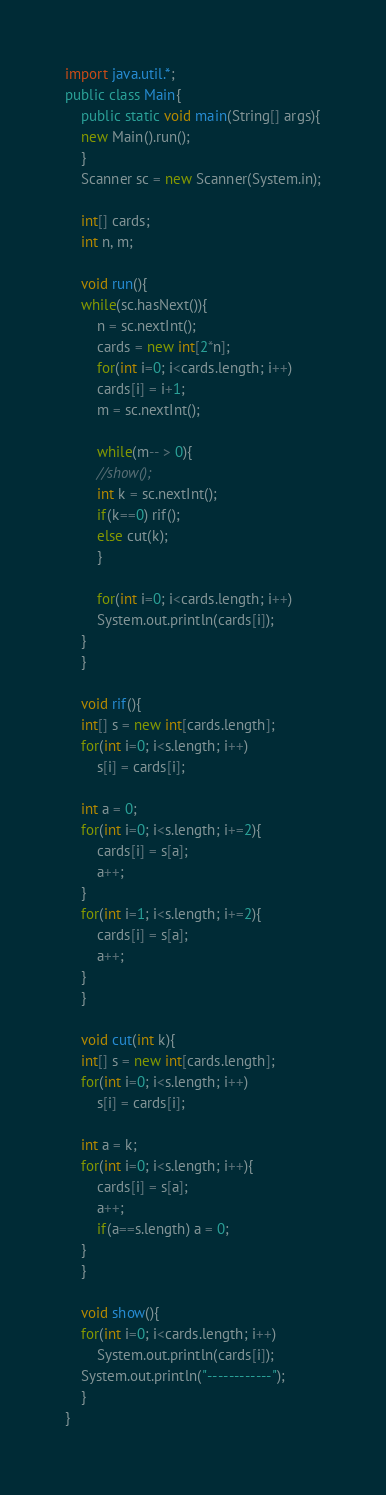Convert code to text. <code><loc_0><loc_0><loc_500><loc_500><_Java_>import java.util.*;
public class Main{
    public static void main(String[] args){
	new Main().run();
    }
    Scanner sc = new Scanner(System.in);

    int[] cards;
    int n, m;

    void run(){
	while(sc.hasNext()){
	    n = sc.nextInt();
	    cards = new int[2*n];
	    for(int i=0; i<cards.length; i++)
		cards[i] = i+1;
	    m = sc.nextInt();

	    while(m-- > 0){
		//show();
		int k = sc.nextInt();
		if(k==0) rif();
		else cut(k);
	    }

	    for(int i=0; i<cards.length; i++)
		System.out.println(cards[i]);
	}
    }

    void rif(){
	int[] s = new int[cards.length];
	for(int i=0; i<s.length; i++)
	    s[i] = cards[i];

	int a = 0;
	for(int i=0; i<s.length; i+=2){
	    cards[i] = s[a];
	    a++;
	}
	for(int i=1; i<s.length; i+=2){
	    cards[i] = s[a];
	    a++;
	}
    }

    void cut(int k){
	int[] s = new int[cards.length];
	for(int i=0; i<s.length; i++)
	    s[i] = cards[i];

	int a = k;
	for(int i=0; i<s.length; i++){
	    cards[i] = s[a];
	    a++;
	    if(a==s.length) a = 0;
	}
    }

    void show(){
	for(int i=0; i<cards.length; i++)
	    System.out.println(cards[i]);
	System.out.println("------------");
    }
}</code> 